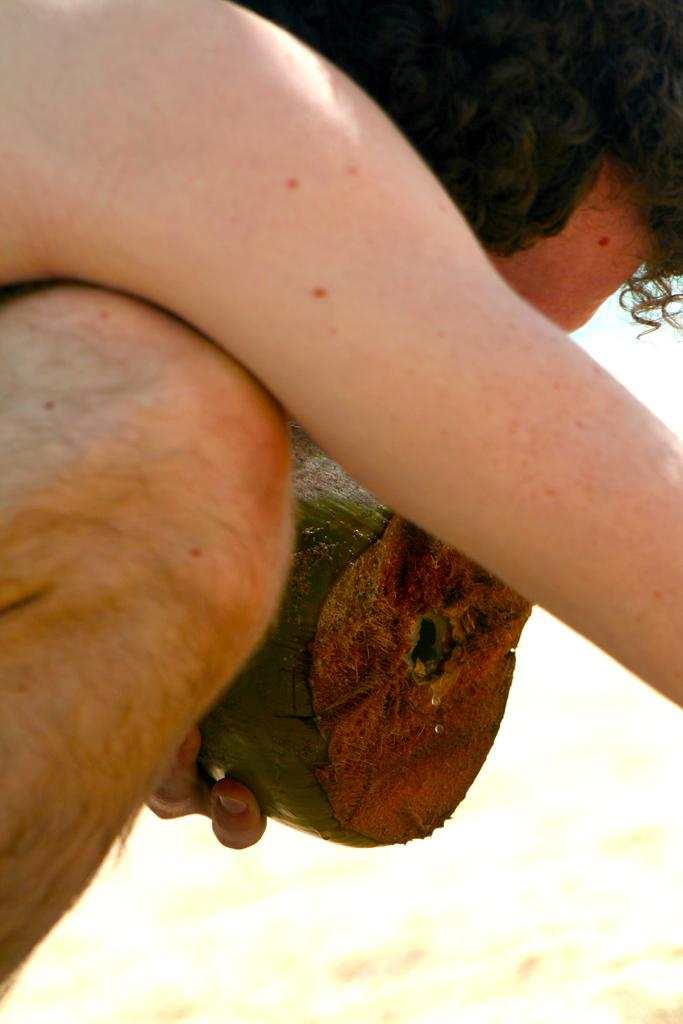What can be seen in the image? There is a person in the image. What is the person doing in the image? The person is holding an object. What is the color of the background in the image? The background of the image is white. Can you tell me how thick the fog is in the image? There is no fog present in the image; the background is white. 